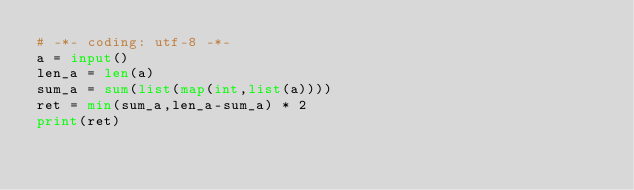Convert code to text. <code><loc_0><loc_0><loc_500><loc_500><_Python_># -*- coding: utf-8 -*-
a = input()
len_a = len(a)
sum_a = sum(list(map(int,list(a))))
ret = min(sum_a,len_a-sum_a) * 2
print(ret)</code> 